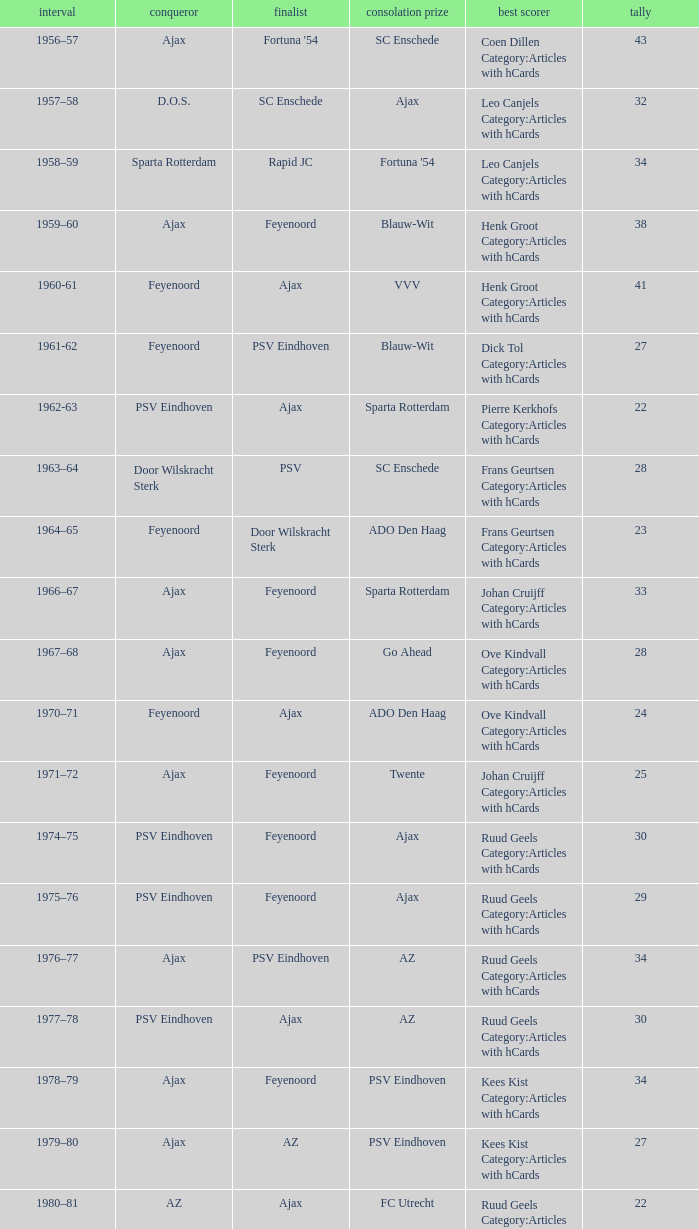When twente came in third place and ajax was the winner what are the seasons? 1971–72, 1989-90. 